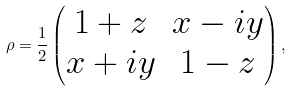<formula> <loc_0><loc_0><loc_500><loc_500>\rho = { \frac { 1 } { 2 } } \begin{pmatrix} 1 + z & x - i y \\ x + i y & 1 - z \end{pmatrix} ,</formula> 